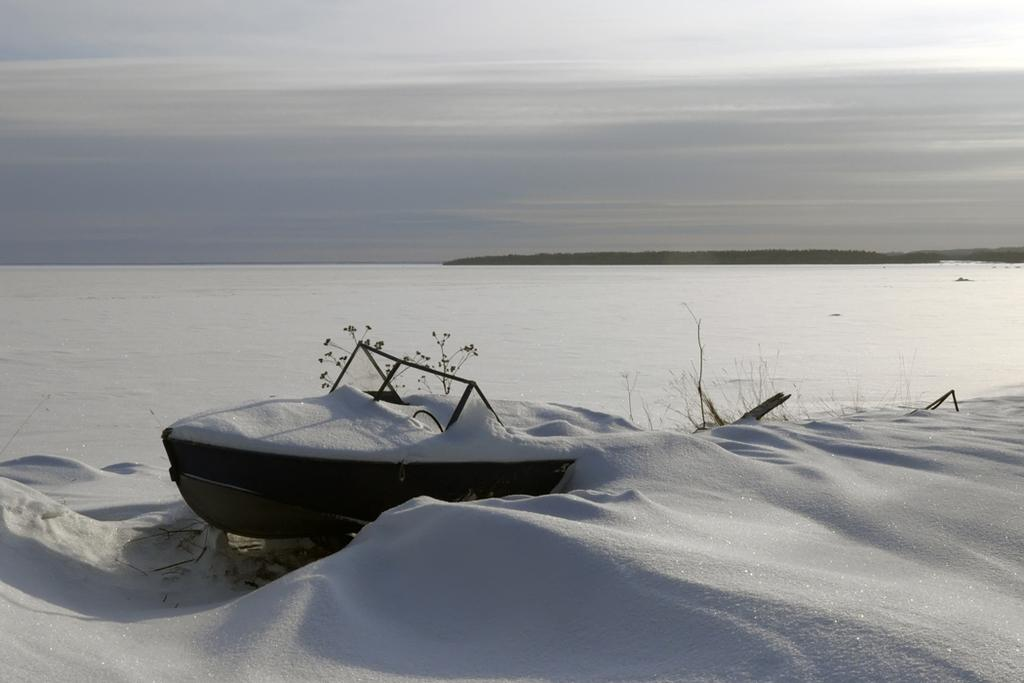What is the main subject of the image? The main subject of the image is a boat. Where is the boat located in the image? The boat is on the snow in the image. What can be seen in the background of the image? Plants and the sky are visible in the background of the image. What type of regret can be seen on the boat in the image? There is no regret present in the image; it is a boat on the snow with plants and the sky visible in the background. 